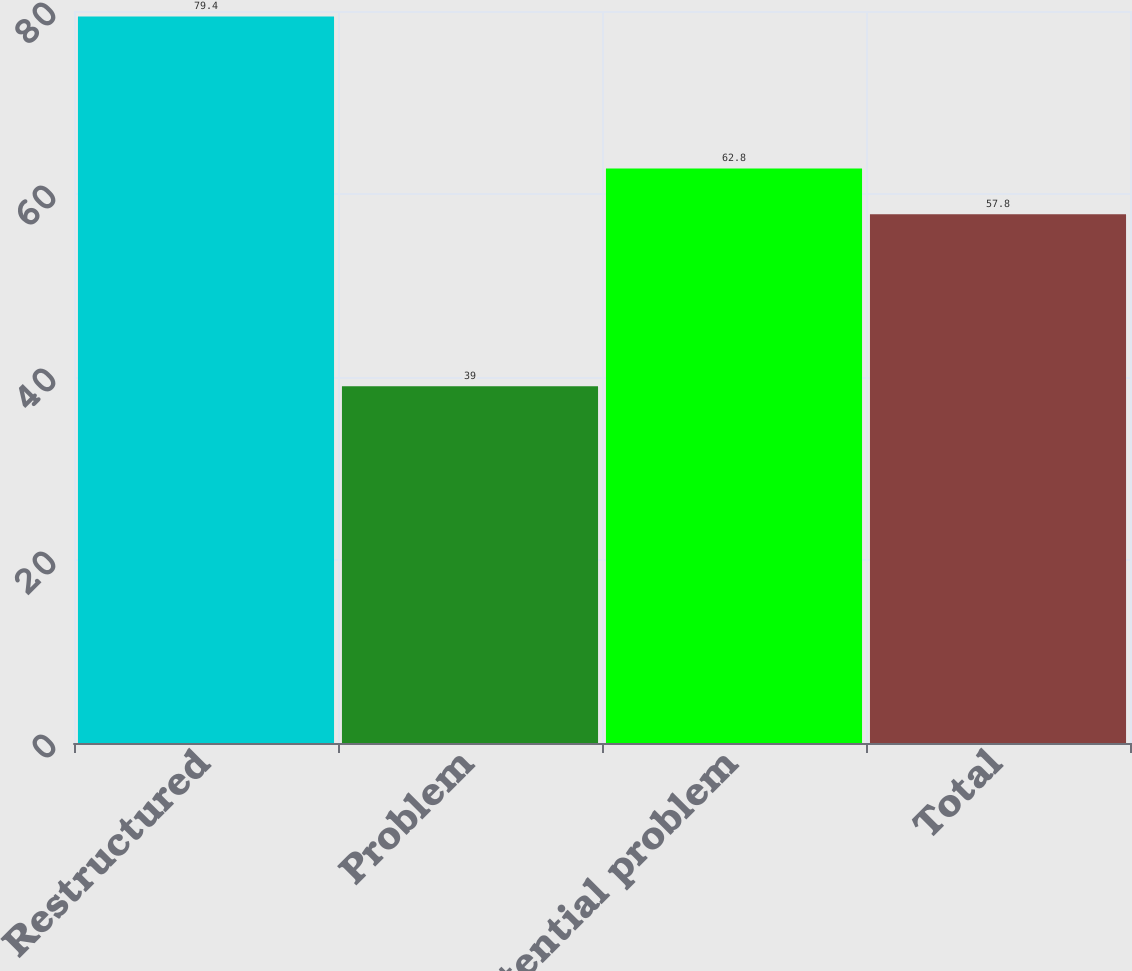Convert chart. <chart><loc_0><loc_0><loc_500><loc_500><bar_chart><fcel>Restructured<fcel>Problem<fcel>Potential problem<fcel>Total<nl><fcel>79.4<fcel>39<fcel>62.8<fcel>57.8<nl></chart> 